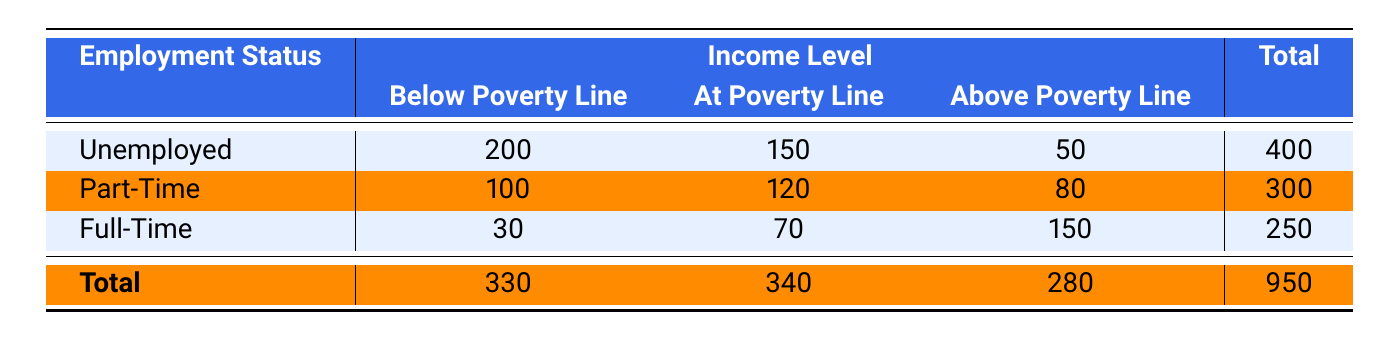What is the total number of unemployed individuals below the poverty line? From the table, the count of unemployed individuals below the poverty line is directly provided as 200.
Answer: 200 What is the total income level of part-time employed individuals? To find this, we sum the counts for part-time employment across all income levels: 100 (Below Poverty Line) + 120 (At Poverty Line) + 80 (Above Poverty Line) = 300.
Answer: 300 Is the number of individuals employed part-time above the poverty line more than those employed full-time below the poverty line? The count of part-time employed individuals above the poverty line is 80, while the count of full-time employed individuals below the poverty line is 30. Since 80 is greater than 30, the answer is yes.
Answer: Yes How many individuals are there in total across all groups at the poverty line? By checking the counts, we find: 150 (Unemployed) + 120 (Part-Time) + 70 (Full-Time) = 340. Thus, the total at the poverty line is 340.
Answer: 340 What is the difference in the number of individuals below the poverty line between unemployed and full-time employees? To find the difference, we take the count of unemployed individuals below the poverty line (200) and subtract the count of full-time employees below the poverty line (30): 200 - 30 = 170.
Answer: 170 How many more individuals are there at the poverty line compared to those above it? We will compare the total counts at the poverty line (340) and above it (280). The difference is 340 - 280 = 60. Therefore, there are 60 more individuals at the poverty line.
Answer: 60 Is it true that the total number of full-time employed individuals is greater than the total number of part-time employed individuals? To determine this, we compare their totals: full-time has 250 and part-time has 300. Since 250 is less than 300, the statement is false.
Answer: No What percentage of total beneficiaries are unemployed? The total number of beneficiaries is 950. The count of unemployed is 400. To find the percentage, we use the formula (400/950) * 100 which equals approximately 42.11%.
Answer: 42.11% 